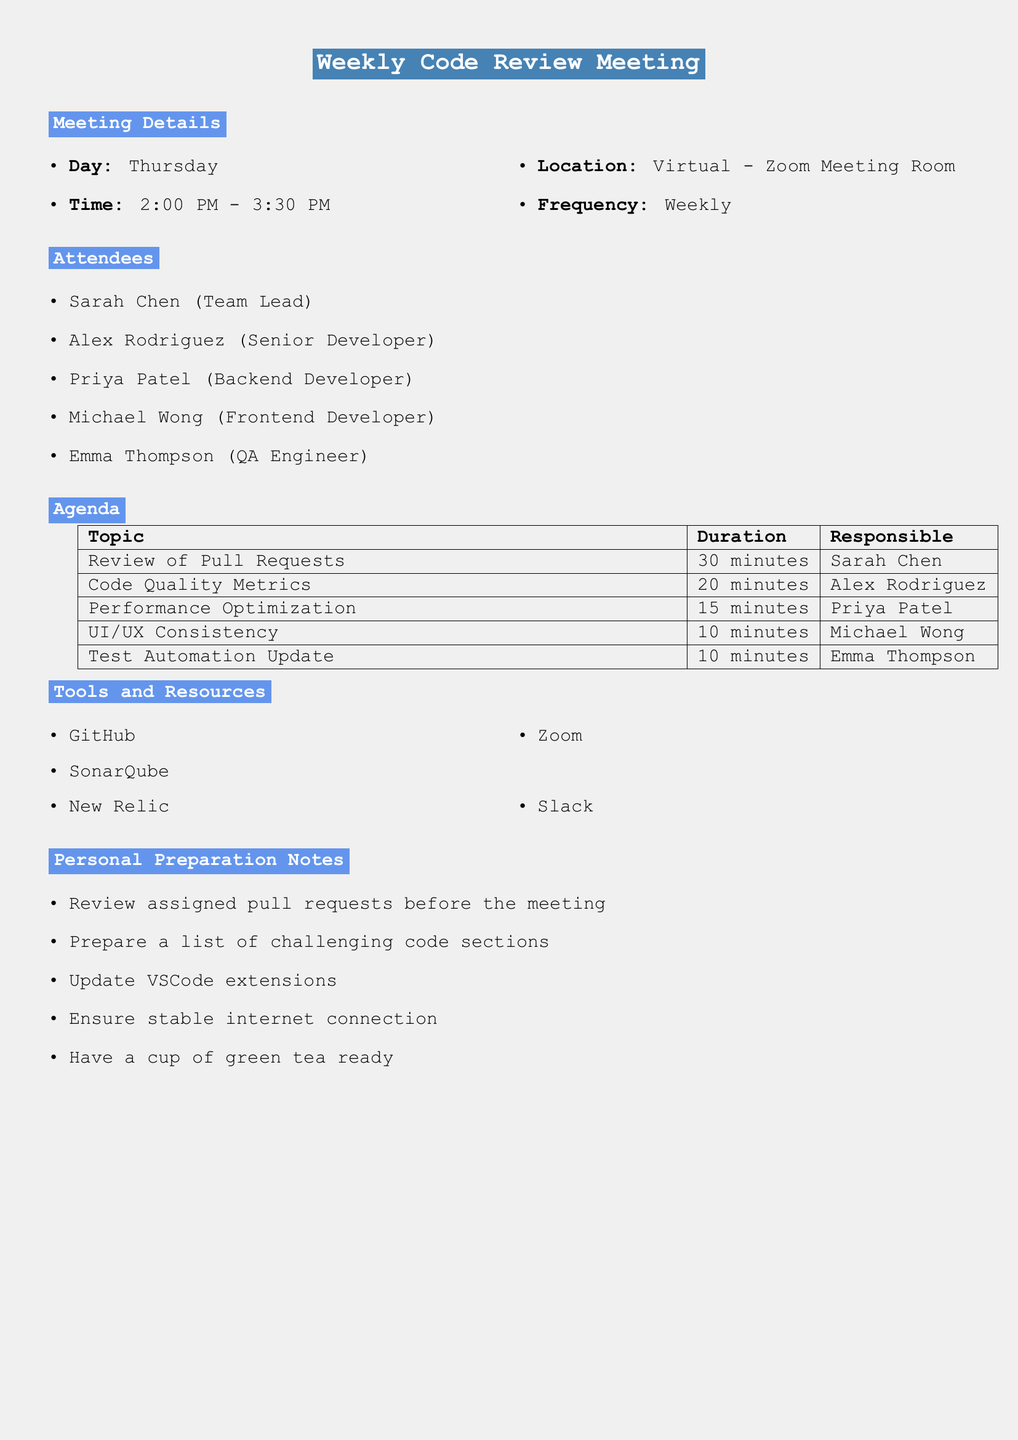What is the title of the meeting? The title can be found at the beginning of the document, which states "Weekly Code Review Meeting."
Answer: Weekly Code Review Meeting On what day does the meeting occur? The document specifies that the meeting takes place on Thursday.
Answer: Thursday Who is responsible for reviewing pull requests? The agenda item specifies that Sarah Chen is responsible for the review of pull requests.
Answer: Sarah Chen How long is the discussion on Code Quality Metrics? The meeting agenda indicates that the discussion on Code Quality Metrics lasts for 20 minutes.
Answer: 20 minutes What tool is used for video conferencing? The tools and resources section lists Zoom as the video conferencing platform.
Answer: Zoom What should attendees do before the meeting? The personal preparation notes advise attendees to review assigned pull requests before the meeting.
Answer: Review assigned pull requests Which attendee is responsible for performance optimization? The agenda indicates that Priya Patel is responsible for discussing performance optimization.
Answer: Priya Patel What is the frequency of the meeting? The details mention that the meeting is held weekly.
Answer: Weekly What is one of the post-meeting actions? The post-meeting actions list includes updating Jira tickets with agreed-upon code changes.
Answer: Update Jira tickets 